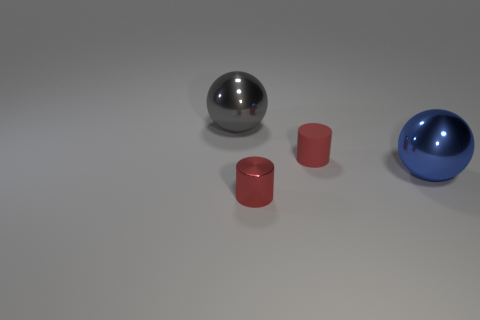Add 3 shiny cylinders. How many objects exist? 7 Subtract all red rubber things. Subtract all metallic cylinders. How many objects are left? 2 Add 3 gray metallic balls. How many gray metallic balls are left? 4 Add 2 small gray blocks. How many small gray blocks exist? 2 Subtract 0 purple blocks. How many objects are left? 4 